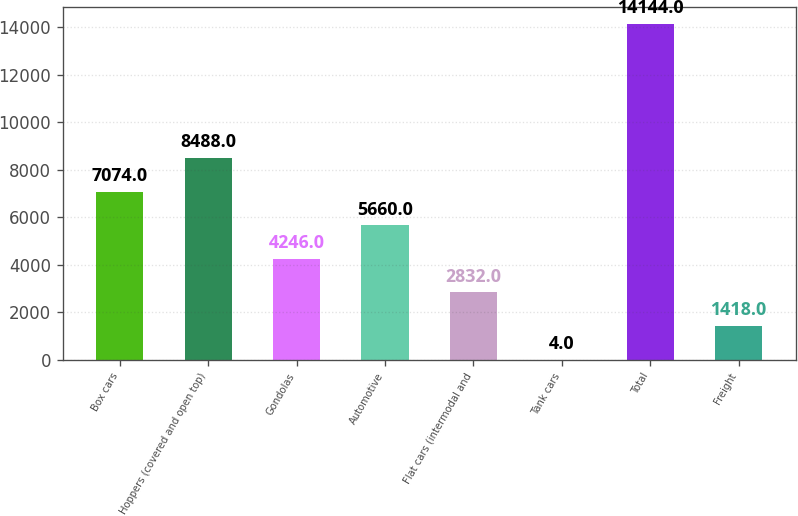Convert chart. <chart><loc_0><loc_0><loc_500><loc_500><bar_chart><fcel>Box cars<fcel>Hoppers (covered and open top)<fcel>Gondolas<fcel>Automotive<fcel>Flat cars (intermodal and<fcel>Tank cars<fcel>Total<fcel>Freight<nl><fcel>7074<fcel>8488<fcel>4246<fcel>5660<fcel>2832<fcel>4<fcel>14144<fcel>1418<nl></chart> 